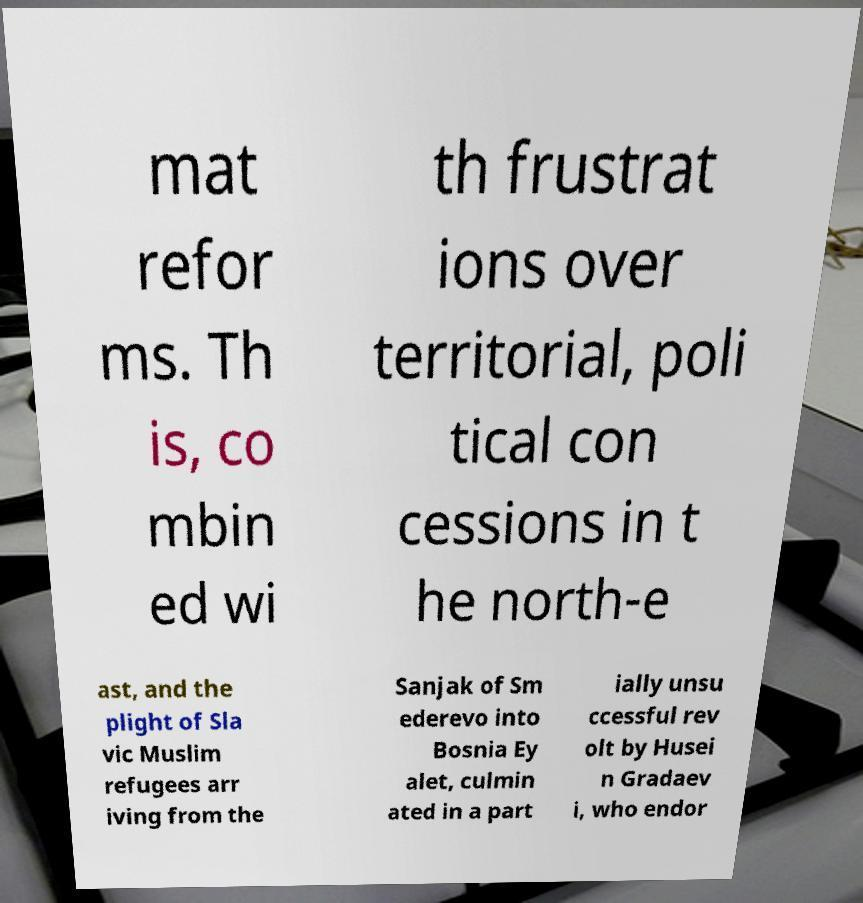Could you extract and type out the text from this image? mat refor ms. Th is, co mbin ed wi th frustrat ions over territorial, poli tical con cessions in t he north-e ast, and the plight of Sla vic Muslim refugees arr iving from the Sanjak of Sm ederevo into Bosnia Ey alet, culmin ated in a part ially unsu ccessful rev olt by Husei n Gradaev i, who endor 